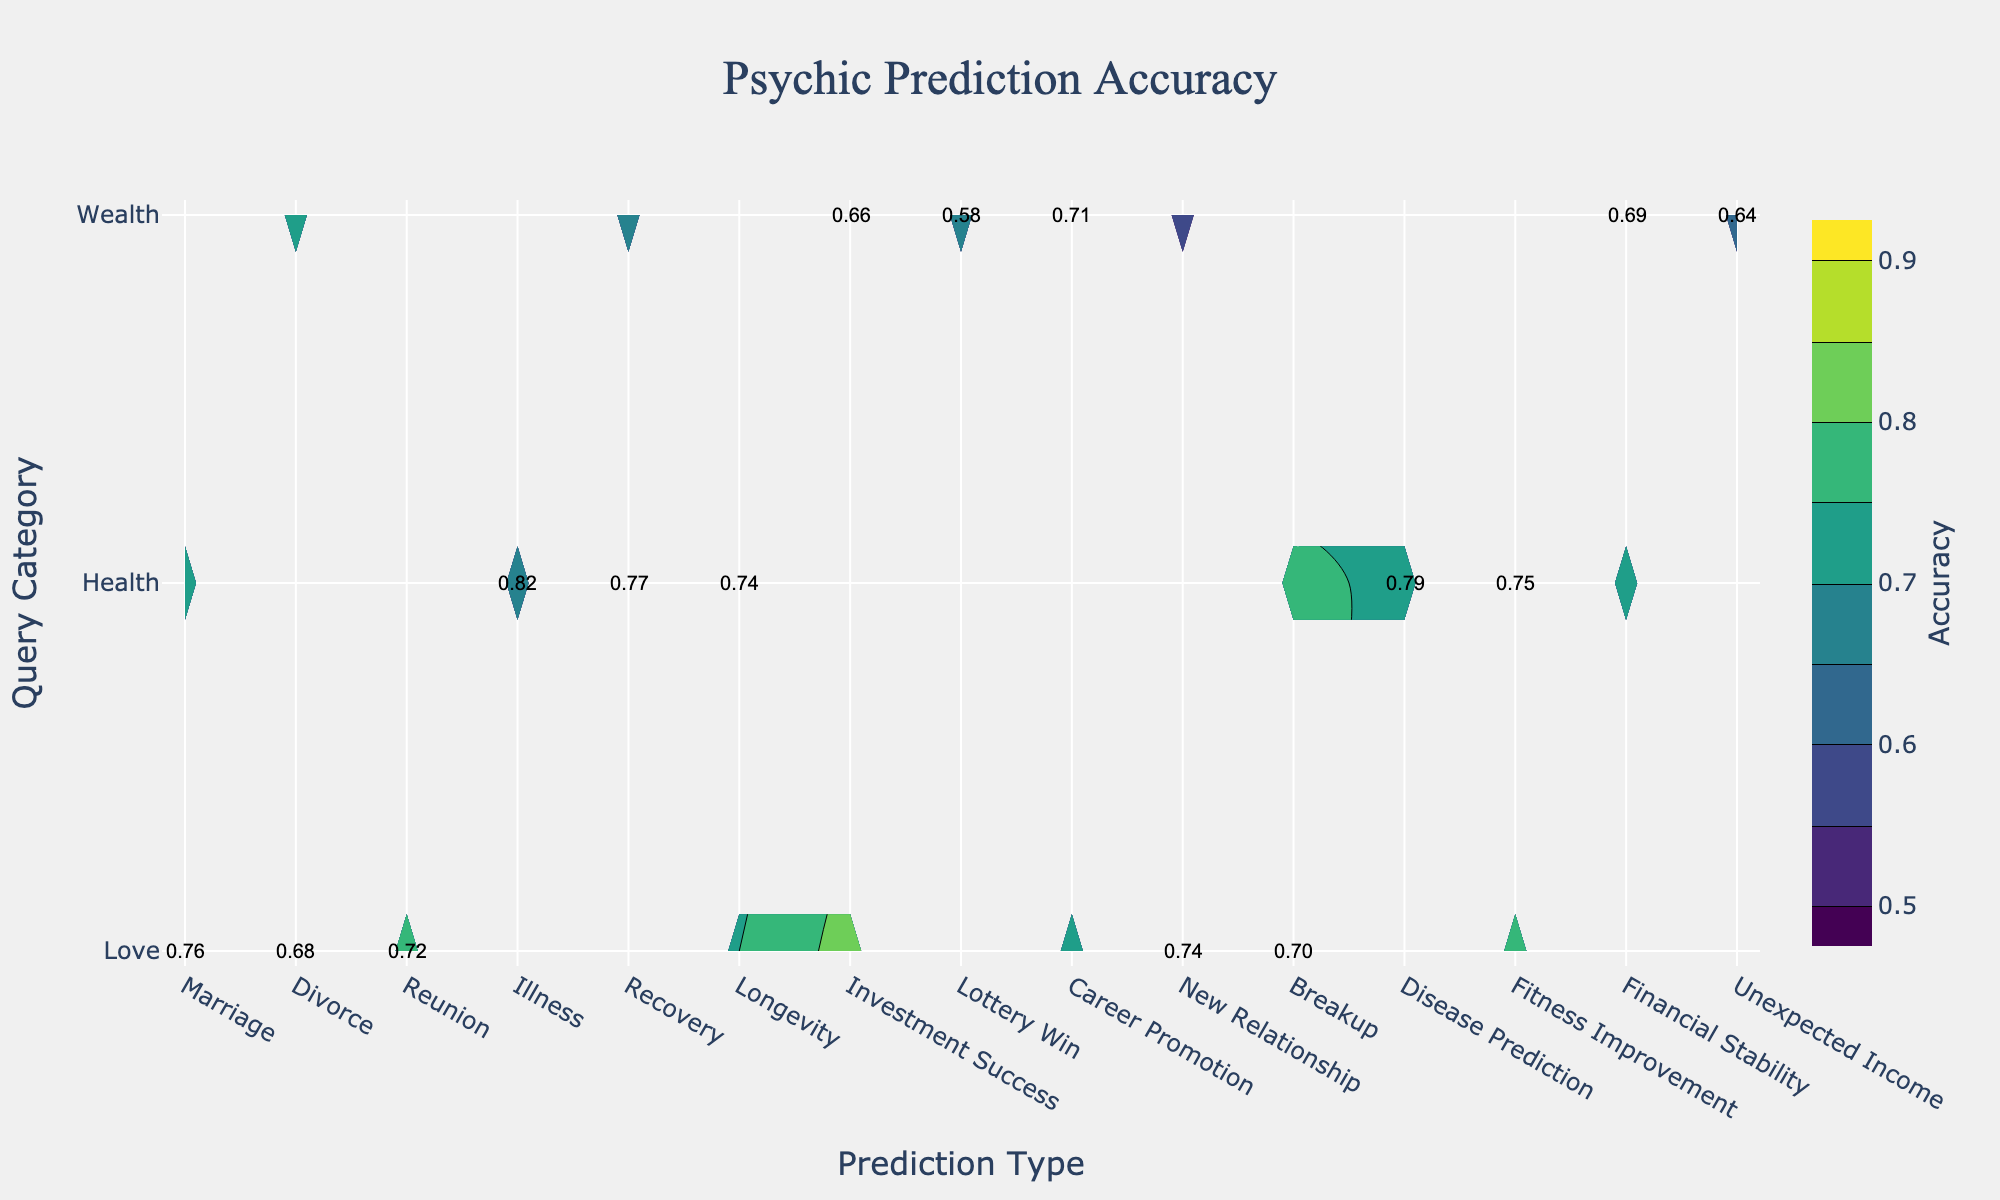What is the highest accuracy prediction type for the query category "Love"? Look at the contour plot for the "Love" row and find the highest labeled value. "Marriage" has the highest accuracy at 0.76.
Answer: Marriage Which prediction type in "Health" query category has the lowest accuracy? In the contour plot for the "Health" row, check the accuracies and find the lowest value. "Longevity" has the lowest accuracy at 0.74.
Answer: Longevity What is the average accuracy for predictions in the "Wealth" category? Calculate the average of all accuracy values within the "Wealth" query category: (0.66 + 0.58 + 0.71 + 0.69 + 0.64) / 5 = 0.656.
Answer: 0.656 Is the accuracy of "New Relationship" prediction higher or lower than that of "Breakup" in the "Love" category? Compare the labeled accuracies for "New Relationship" (0.74) and "Breakup" (0.70). "New Relationship" has a higher accuracy.
Answer: Higher What is the overall trend in accuracy across different query categories? Analyze the contour lines and values across different query categories ("Love", "Health", "Wealth"). Health has relatively higher accuracy values, followed by Love, then Wealth.
Answer: Health > Love > Wealth Which prediction type has the smallest accuracy difference within any query category, and what is that difference? Find the smallest absolute difference in accuracies within any query category. In the "Health" category, the differences are: 0.82-0.77=0.05 (Illness and Recovery). Hence, smallest difference is 0.05.
Answer: Illness and Recovery, 0.05 What's the median accuracy value for predictions in the "Love" query category? Order the accuracies in the "Love" category: (0.68, 0.70, 0.72, 0.74, 0.74, 0.76). The median value is the average of the 3rd and 4th values: (0.72 + 0.74) / 2 = 0.73.
Answer: 0.73 Which query category has the most uniform accuracy across its prediction types? Evaluate uniformity by comparing differences among accuracy values within each query category. The "Health" category has the smallest range of differences, suggesting more uniformity.
Answer: Health Which prediction type has the highest single accuracy value across all query categories? Inspect all labeled accuracies to find the highest value. "Illness" in the "Health" category has the highest accuracy at 0.82.
Answer: Illness 